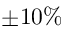Convert formula to latex. <formula><loc_0><loc_0><loc_500><loc_500>\pm 1 0 \%</formula> 